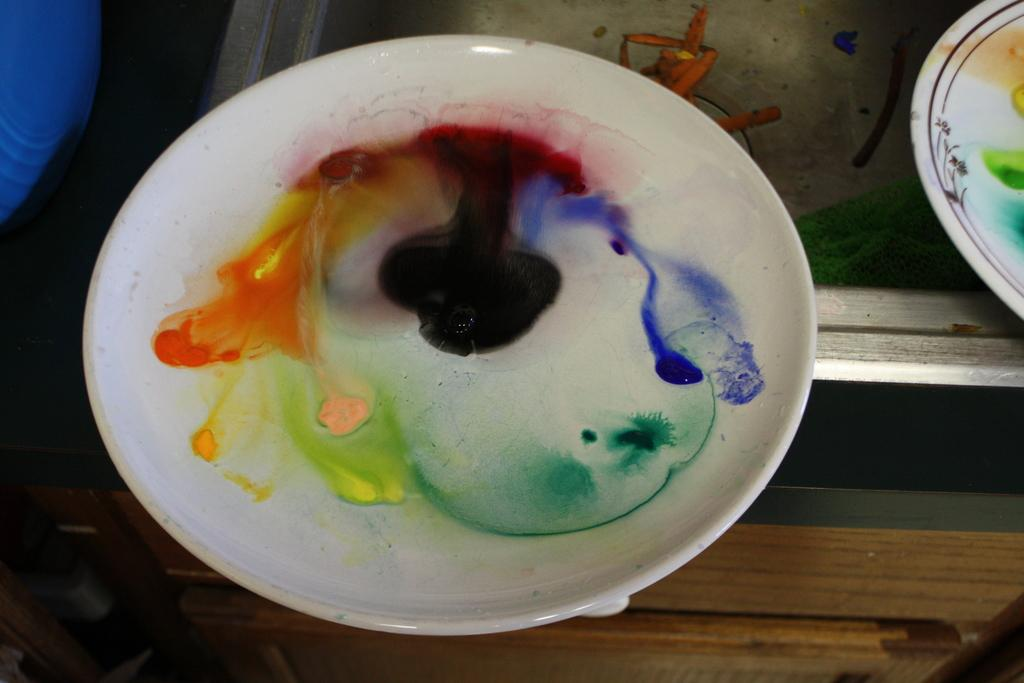What objects are present in the image? There are plates in the image. What can be observed about the appearance of the plates? The plates have colors on their surface. Where are the plates located in the image? The plates are on a surface that resembles a table. Are there any pigs interacting with the plates in the image? There are no pigs present in the image. What type of plants can be seen growing on the plates in the image? There are no plants growing on the plates in the image. 